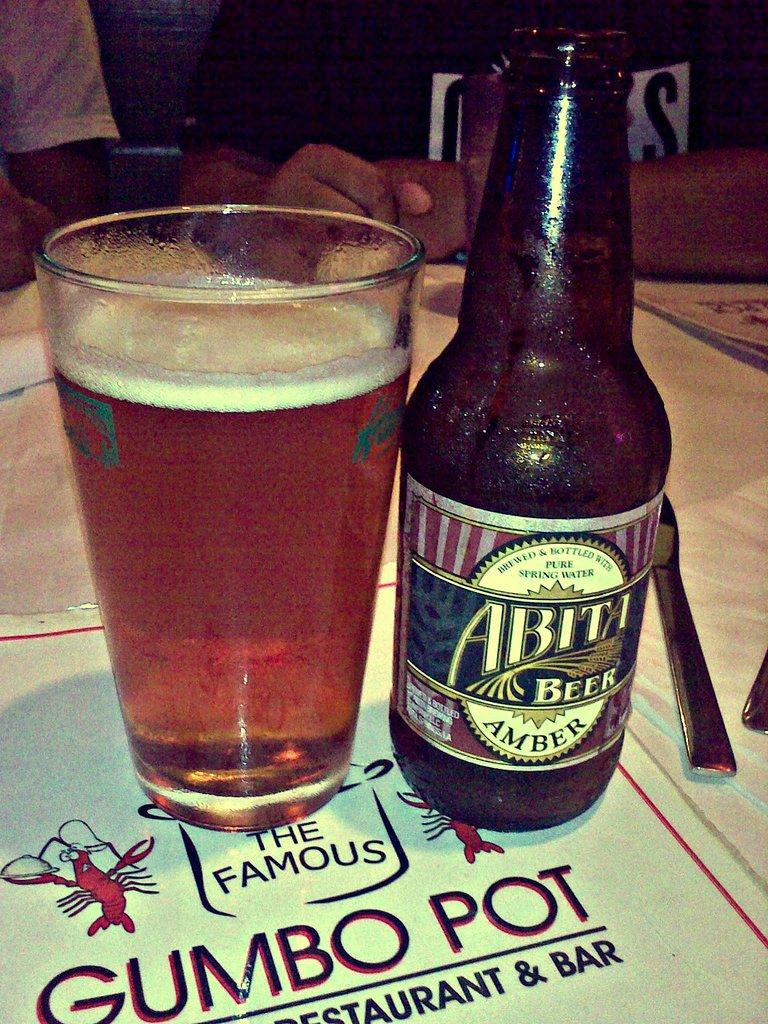<image>
Create a compact narrative representing the image presented. A bottle of Abita beer is next to a full glass and both are sitting on a menu. 